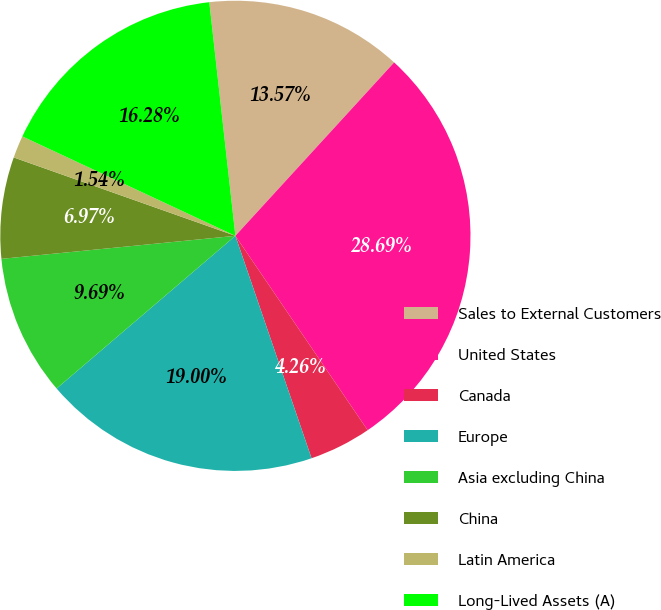Convert chart to OTSL. <chart><loc_0><loc_0><loc_500><loc_500><pie_chart><fcel>Sales to External Customers<fcel>United States<fcel>Canada<fcel>Europe<fcel>Asia excluding China<fcel>China<fcel>Latin America<fcel>Long-Lived Assets (A)<nl><fcel>13.57%<fcel>28.69%<fcel>4.26%<fcel>19.0%<fcel>9.69%<fcel>6.97%<fcel>1.54%<fcel>16.28%<nl></chart> 